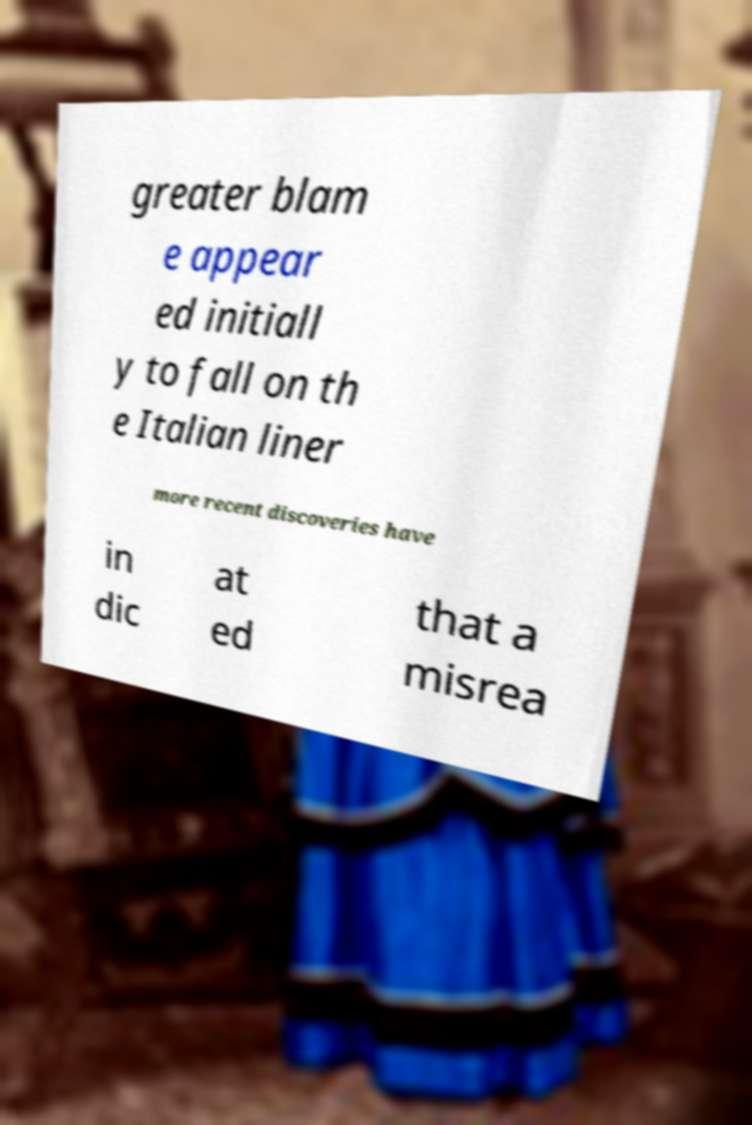What messages or text are displayed in this image? I need them in a readable, typed format. greater blam e appear ed initiall y to fall on th e Italian liner more recent discoveries have in dic at ed that a misrea 